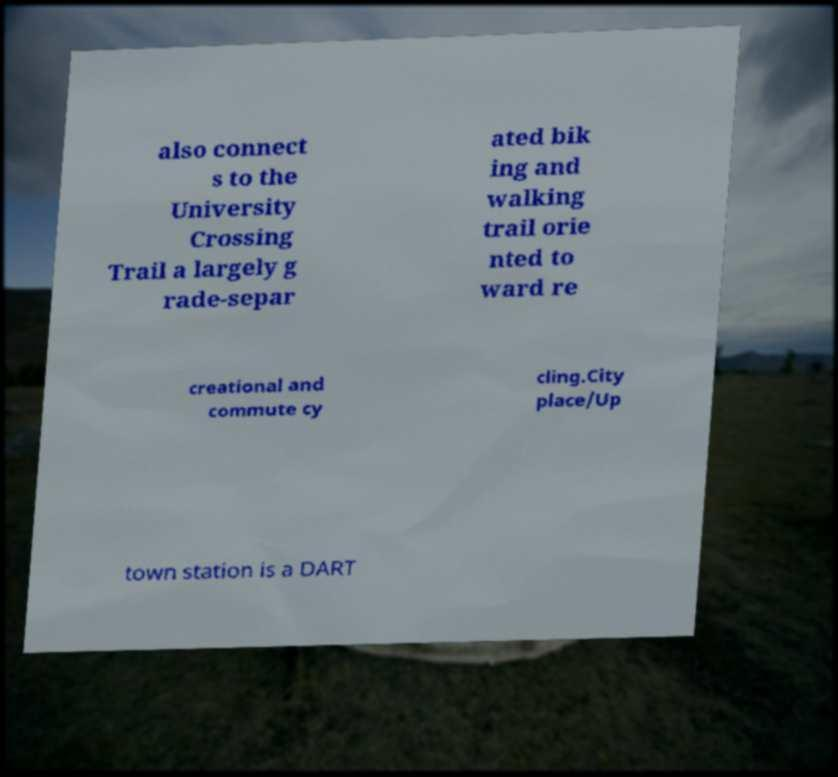Can you read and provide the text displayed in the image?This photo seems to have some interesting text. Can you extract and type it out for me? also connect s to the University Crossing Trail a largely g rade-separ ated bik ing and walking trail orie nted to ward re creational and commute cy cling.City place/Up town station is a DART 